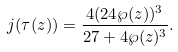<formula> <loc_0><loc_0><loc_500><loc_500>j ( \tau ( z ) ) = \frac { 4 ( 2 4 \wp ( z ) ) ^ { 3 } } { 2 7 + 4 \wp ( z ) ^ { 3 } } .</formula> 